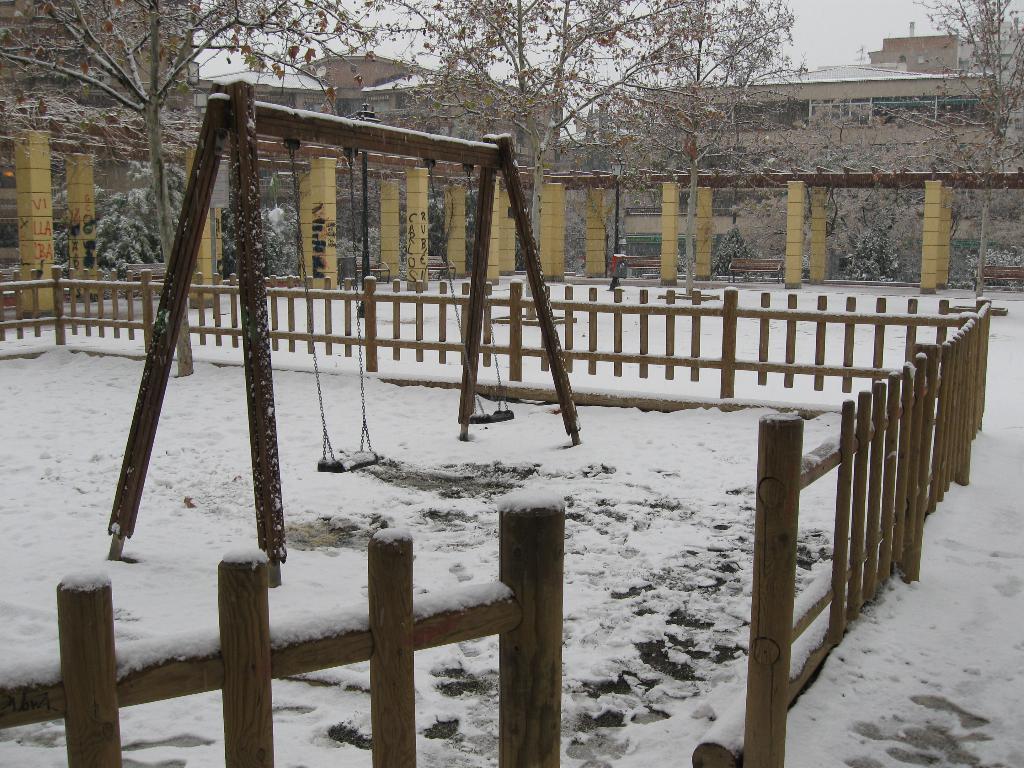Describe this image in one or two sentences. In this image we can see a swing, here is the snow, there is the fencing, there are the trees, here are the pillars, there is the building, at above here is the sky. 